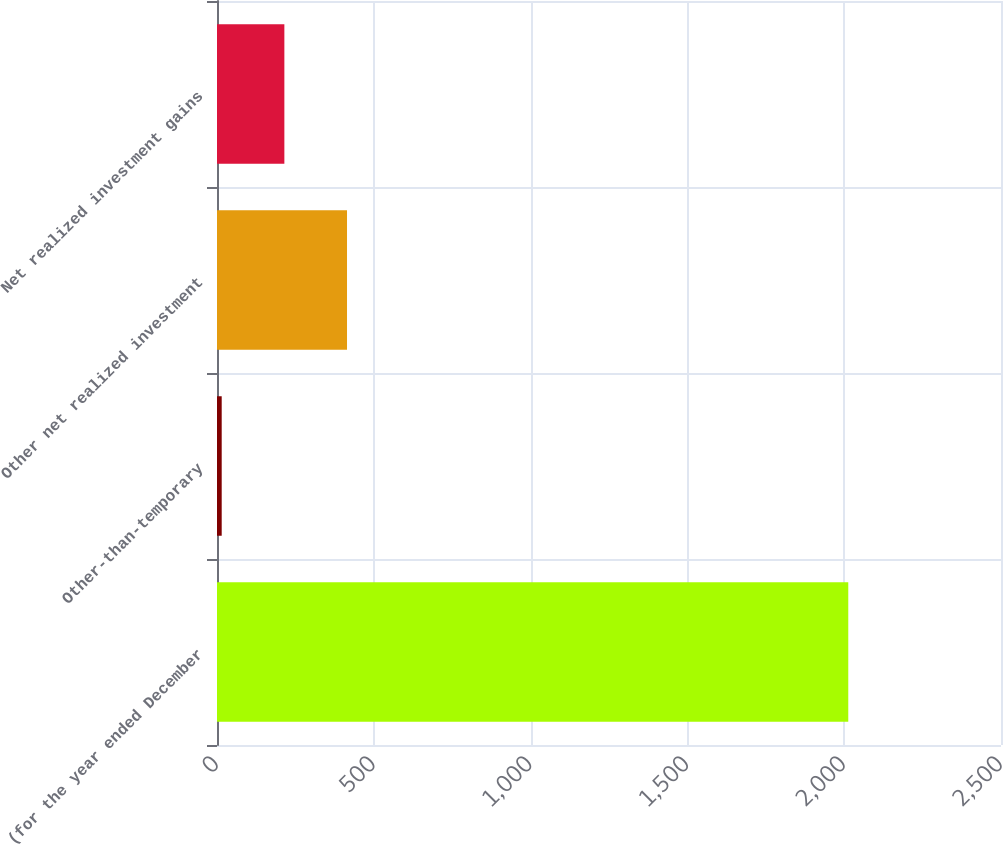Convert chart to OTSL. <chart><loc_0><loc_0><loc_500><loc_500><bar_chart><fcel>(for the year ended December<fcel>Other-than-temporary<fcel>Other net realized investment<fcel>Net realized investment gains<nl><fcel>2013<fcel>15<fcel>414.6<fcel>214.8<nl></chart> 